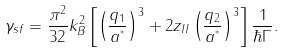<formula> <loc_0><loc_0><loc_500><loc_500>\gamma _ { s f } = \frac { \pi ^ { 2 } } { 3 2 } k ^ { 2 } _ { B } \left [ \left ( \frac { q _ { 1 } } { a ^ { ^ { * } } } \right ) ^ { 3 } + 2 z _ { I I } \left ( \frac { q _ { 2 } } { a ^ { ^ { * } } } \right ) ^ { 3 } \right ] \frac { 1 } { \hbar { \Gamma } } .</formula> 